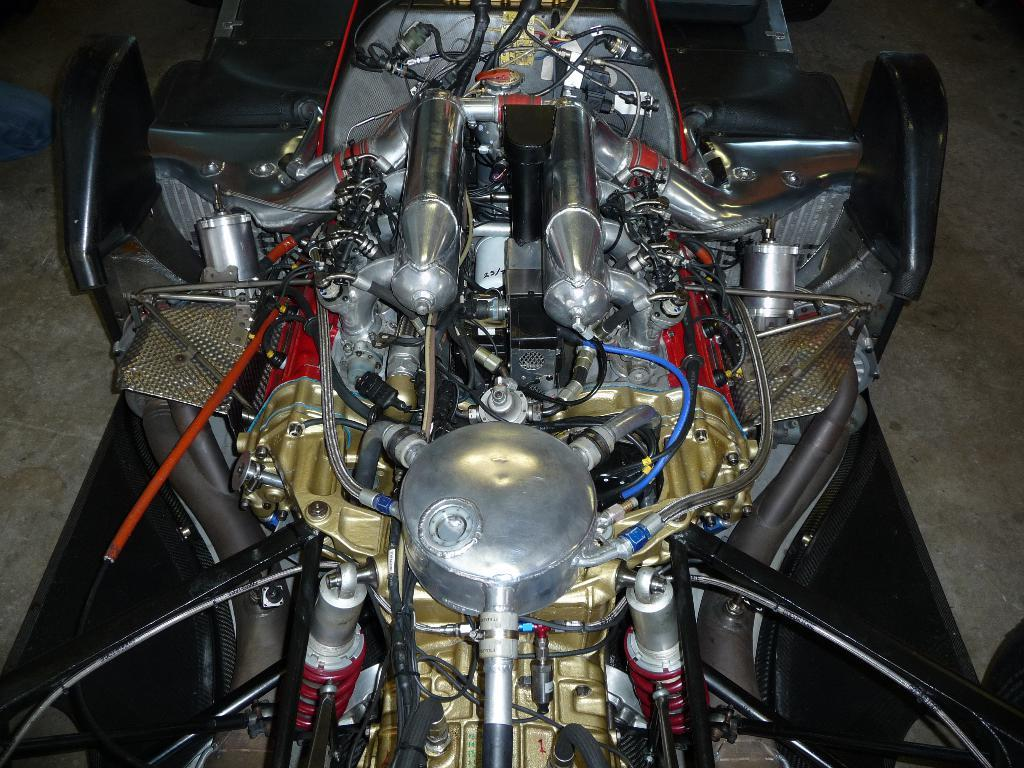What is the main subject of the image? The main subject of the image is a vehicle engine part. What type of soup is being prepared in the image? There is no soup present in the image; it features a vehicle engine part. What kind of paste is being used to apply to the engine part in the image? There is no paste present in the image; it only shows a vehicle engine part. 